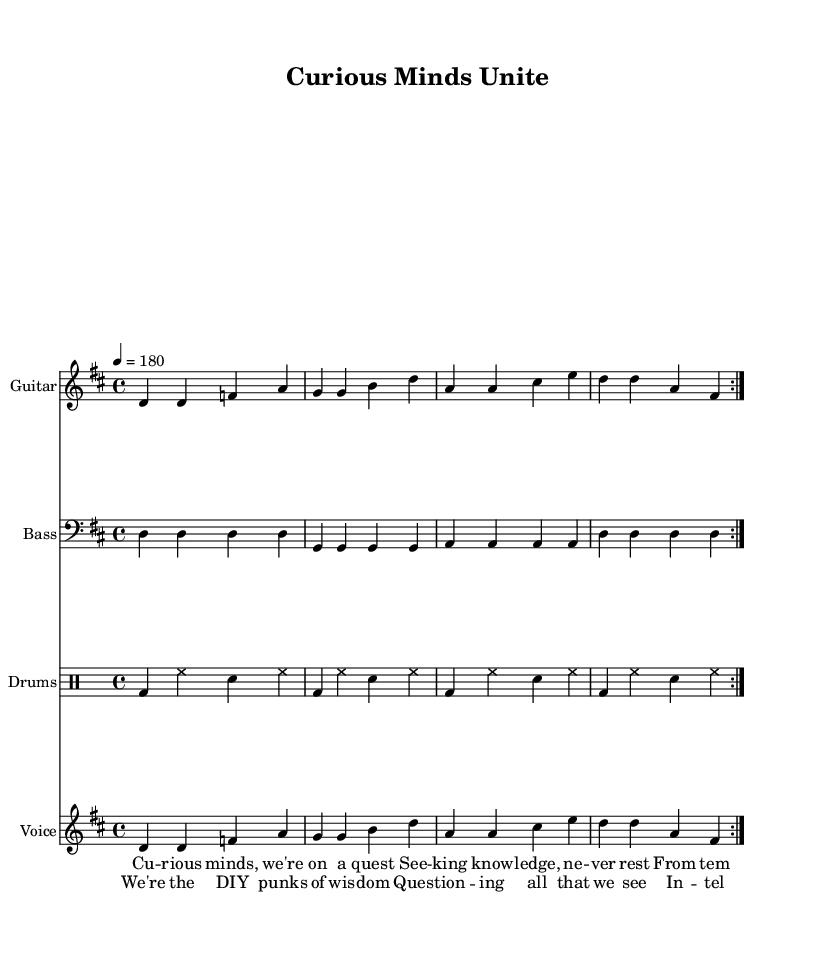What is the key signature of this music? The key signature is D major, which has two sharps (F# and C#). It is indicated at the beginning of the staff.
Answer: D major What is the time signature of this music? The time signature is 4/4, meaning there are four beats per measure and the quarter note receives one beat. This is shown at the beginning of the piece.
Answer: 4/4 What is the tempo marking of this music? The tempo marking is a quarter note equals 180 beats per minute, which indicates a fast tempo for the piece. This is indicated near the beginning of the score.
Answer: 180 What instruments are used in this score? The instruments used are electric guitar, bass, and drums, as specified in the staff names in the score.
Answer: Electric guitar, bass, drums How many measures are in the repeated sections of the electric guitar part? The electric guitar part contains 8 measures due to the repeated volta that occurs twice, making the total 4 measures played twice.
Answer: 8 What themes are presented in the lyrics of the song? The themes presented in the lyrics include intellectual curiosity, the pursuit of knowledge, and exploration of different places of worship, indicated in the verses.
Answer: Intellectual curiosity, pursuit of knowledge What is the primary mood of this punk track based on the title and lyrics? The primary mood of this punk track is one of empowerment and enthusiasm towards learning and questioning, which is expressed in both the title and the lyrics.
Answer: Empowerment, enthusiasm 